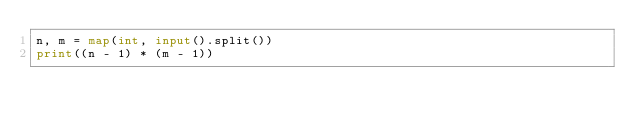<code> <loc_0><loc_0><loc_500><loc_500><_Python_>n, m = map(int, input().split())
print((n - 1) * (m - 1))
</code> 